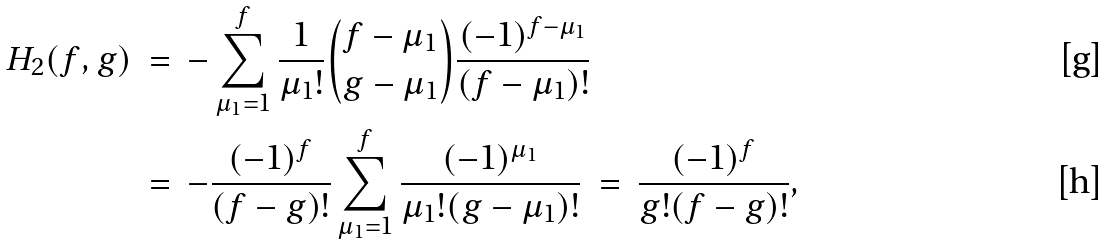Convert formula to latex. <formula><loc_0><loc_0><loc_500><loc_500>H _ { 2 } ( f , g ) \ & = \ - \sum _ { \mu _ { 1 } = 1 } ^ { f } \frac { 1 } { \mu _ { 1 } ! } \binom { f - \mu _ { 1 } } { g - \mu _ { 1 } } \frac { ( - 1 ) ^ { f - \mu _ { 1 } } } { ( f - \mu _ { 1 } ) ! } \\ & = \ - \frac { ( - 1 ) ^ { f } } { ( f - g ) ! } \sum _ { \mu _ { 1 } = 1 } ^ { f } \frac { ( - 1 ) ^ { \mu _ { 1 } } } { \mu _ { 1 } ! ( g - \mu _ { 1 } ) ! } \ = \ \frac { ( - 1 ) ^ { f } } { g ! ( f - g ) ! } ,</formula> 